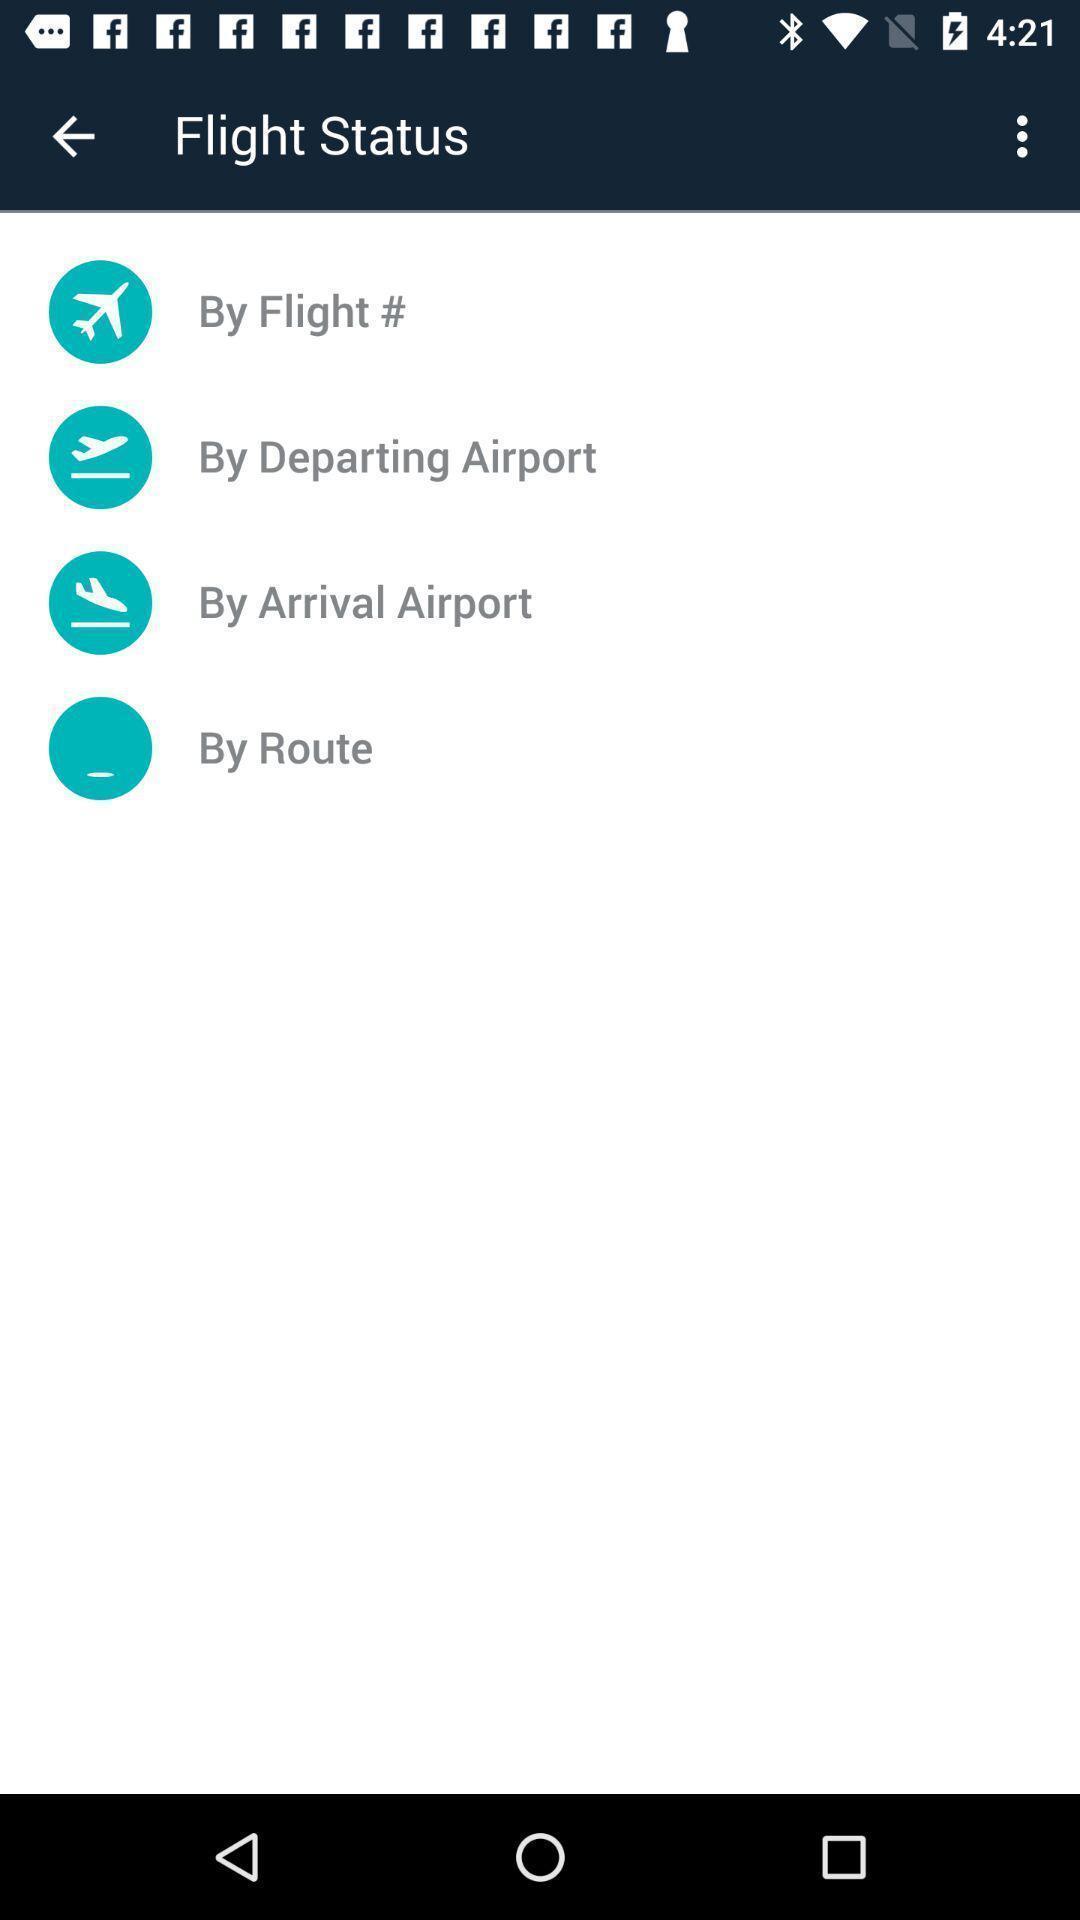Explain what's happening in this screen capture. Various filter displayed regarding flight travel. 